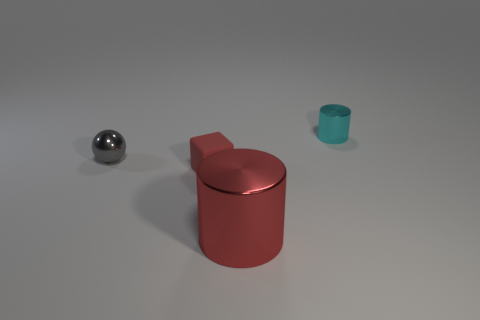Add 1 big metallic things. How many objects exist? 5 Subtract all spheres. How many objects are left? 3 Subtract 0 green balls. How many objects are left? 4 Subtract 1 spheres. How many spheres are left? 0 Subtract all cyan cylinders. Subtract all brown blocks. How many cylinders are left? 1 Subtract all green cubes. How many yellow cylinders are left? 0 Subtract all small gray things. Subtract all rubber objects. How many objects are left? 2 Add 1 large metallic objects. How many large metallic objects are left? 2 Add 3 tiny cyan metallic things. How many tiny cyan metallic things exist? 4 